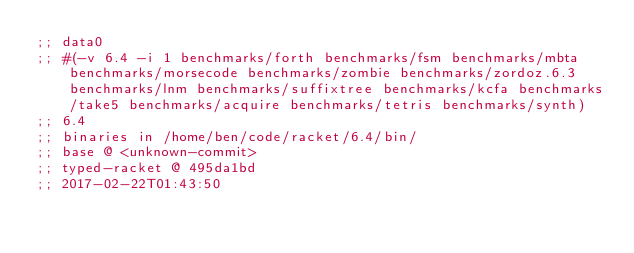<code> <loc_0><loc_0><loc_500><loc_500><_Racket_>;; data0
;; #(-v 6.4 -i 1 benchmarks/forth benchmarks/fsm benchmarks/mbta benchmarks/morsecode benchmarks/zombie benchmarks/zordoz.6.3 benchmarks/lnm benchmarks/suffixtree benchmarks/kcfa benchmarks/take5 benchmarks/acquire benchmarks/tetris benchmarks/synth)
;; 6.4
;; binaries in /home/ben/code/racket/6.4/bin/
;; base @ <unknown-commit>
;; typed-racket @ 495da1bd
;; 2017-02-22T01:43:50</code> 